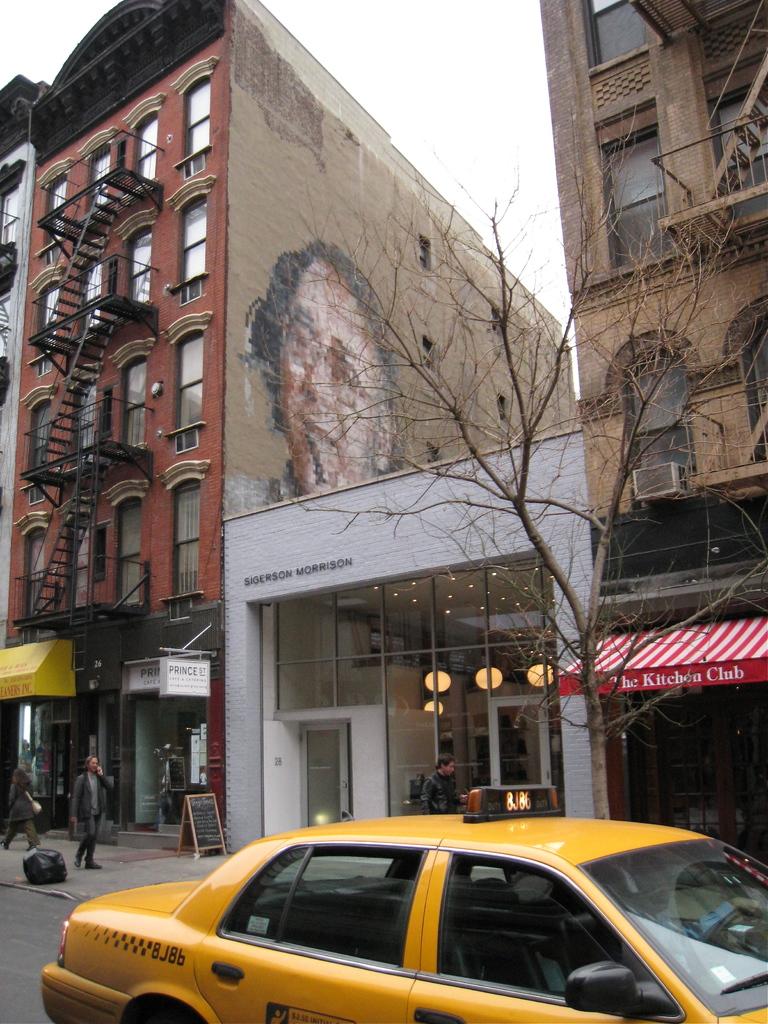What is the name of the place with the red and white awning?
Offer a very short reply. The kitchen club. 